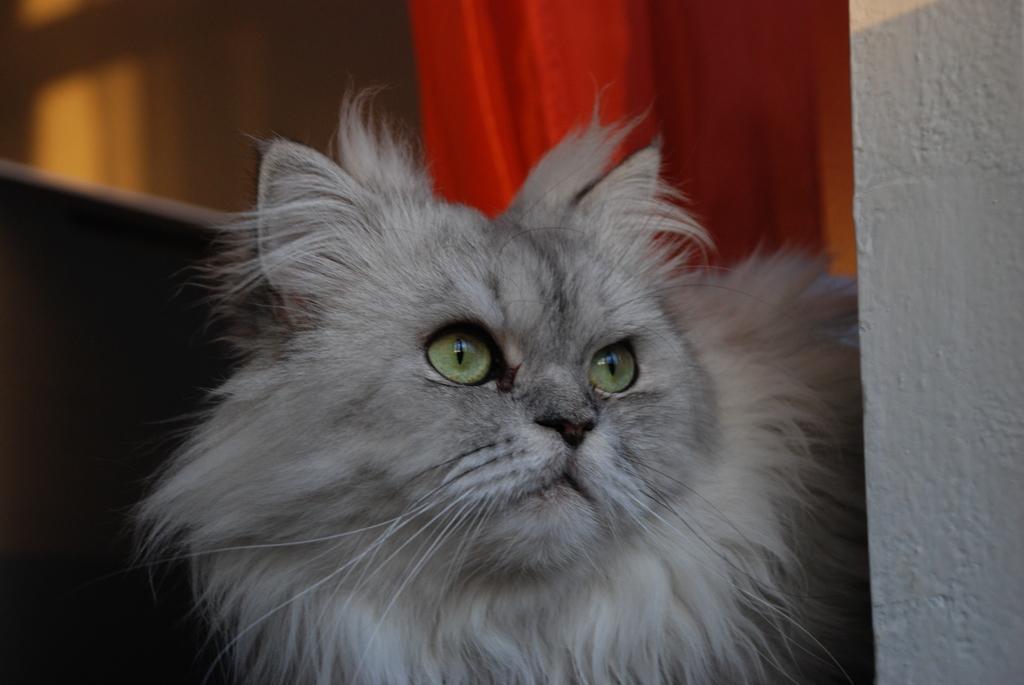How would you summarize this image in a sentence or two? In this image in the foreground there is one cat and in the background is a couch curtains, on the right side there is a wall. 